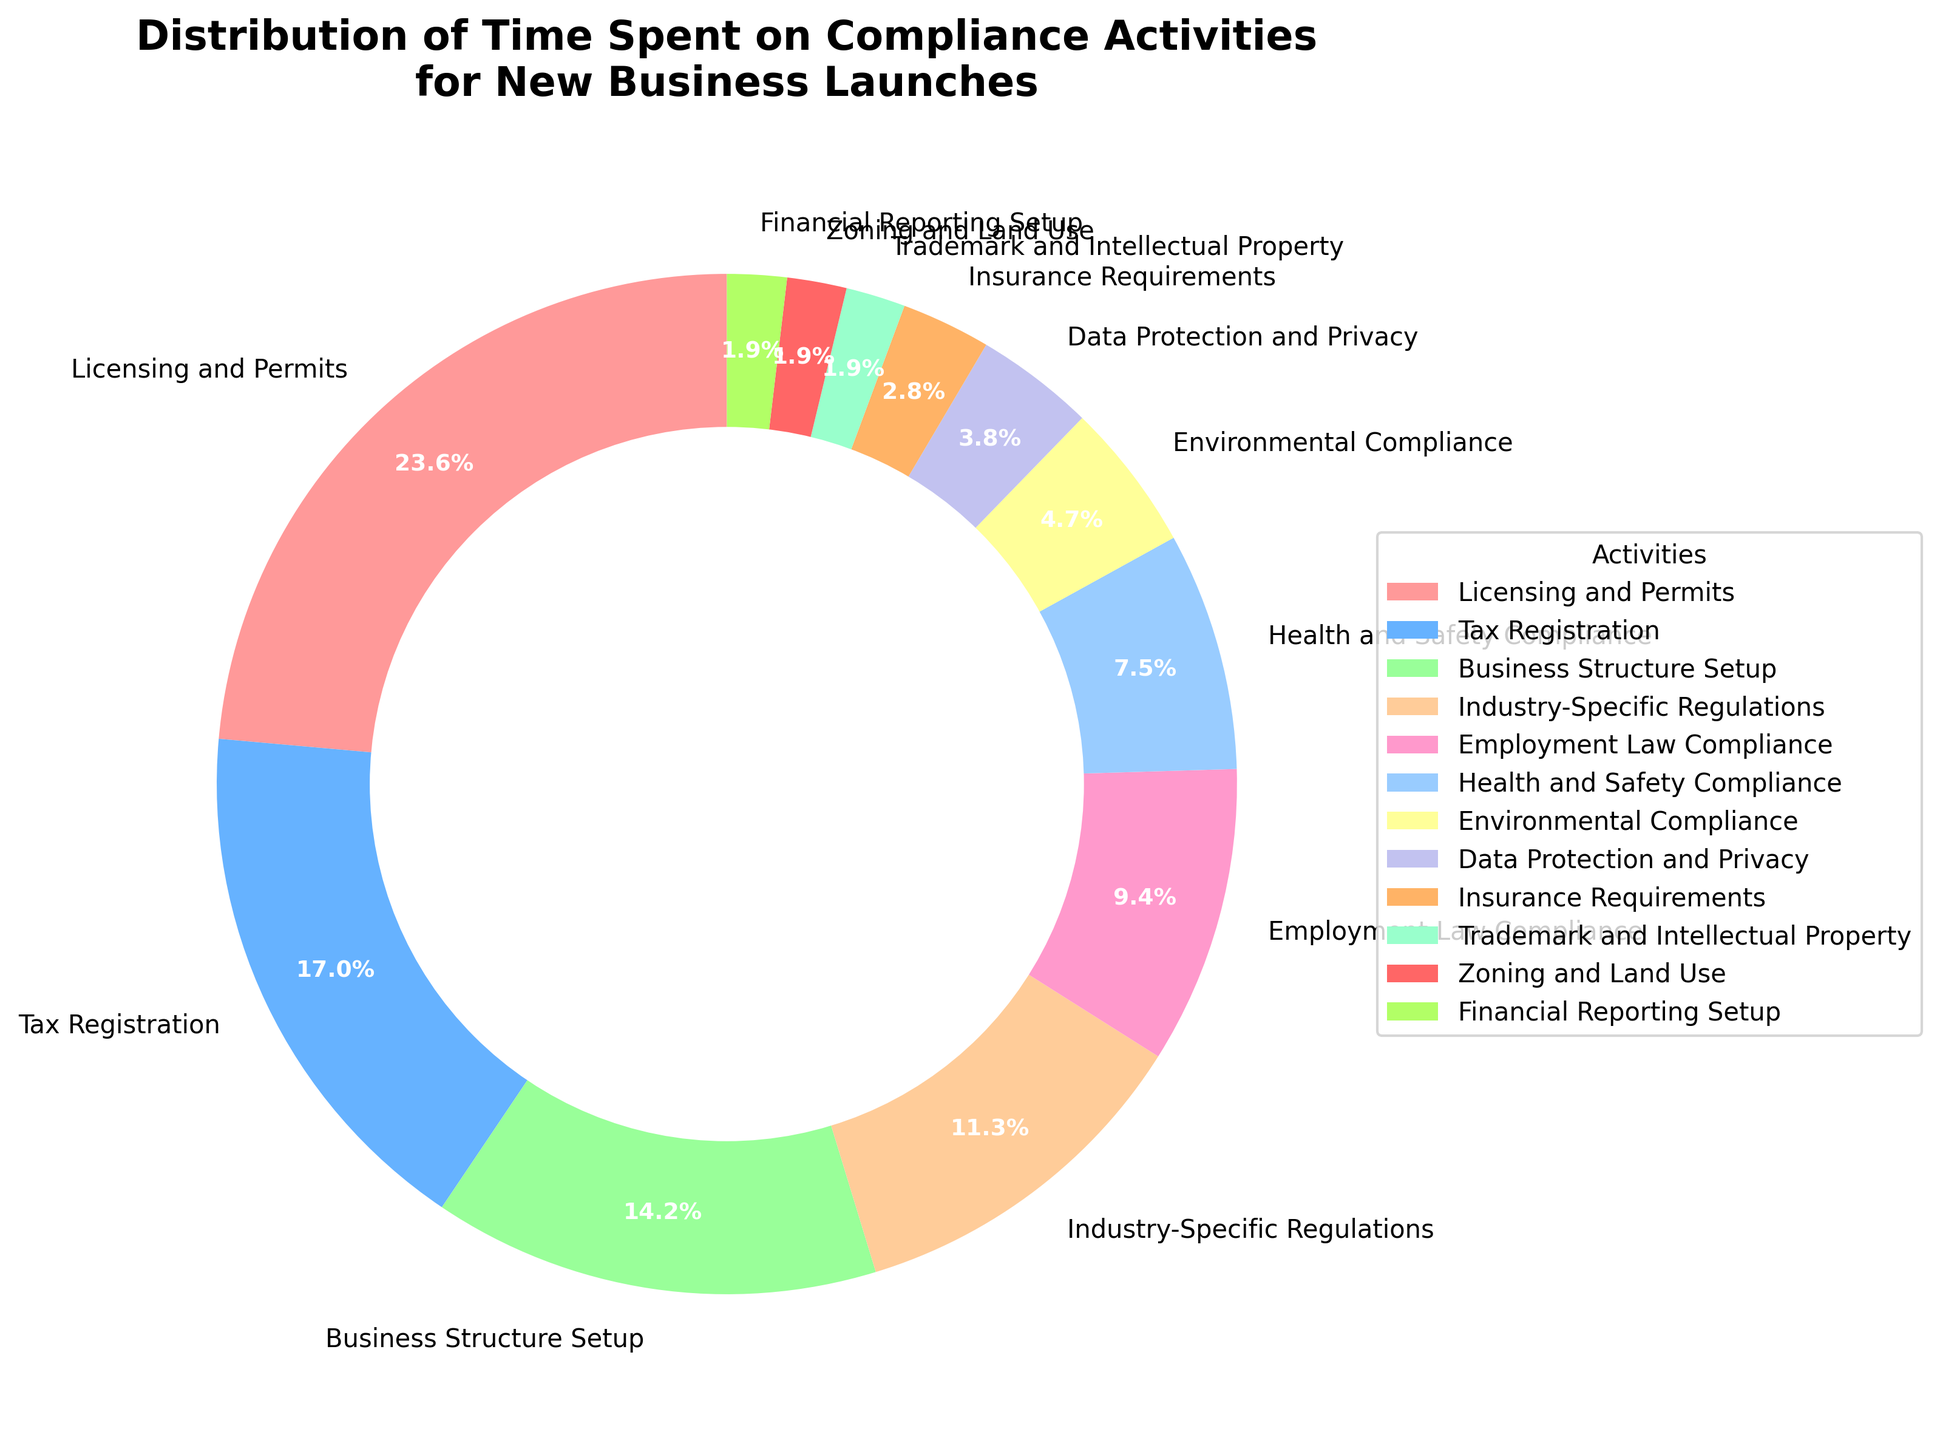What activity takes up the largest proportion of time in compliance tasks for new business launches? By looking at the pie chart, we can see that the largest wedge is labeled "Licensing and Permits" with 25% of the time allocated to this activity.
Answer: Licensing and Permits How much more time is spent on Licensing and Permits compared to Tax Registration? Licensing and Permits takes up 25% of the time, while Tax Registration takes up 18%. The difference in time spent is 25% - 18% = 7%.
Answer: 7% Which compliance activity takes up the least proportion of time? By observing the smallest wedge in the pie chart, "Zoning and Land Use" along with "Financial Reporting Setup", both taking up 2% of the time each, are the smallest.
Answer: Zoning and Land Use; Financial Reporting Setup What is the total percentage of time spent on Health and Safety Compliance, Environmental Compliance, and Data Protection and Privacy combined? Health and Safety Compliance is 8%, Environmental Compliance is 5%, and Data Protection and Privacy is 4%. Adding these together: 8% + 5% + 4% = 17%.
Answer: 17% How does the time spent on Employment Law Compliance compare to Health and Safety Compliance? Employment Law Compliance takes 10% of the time, while Health and Safety Compliance takes 8%. Therefore, more time is spent on Employment Law Compliance by a difference of 2%.
Answer: Employment Law Compliance takes 2% more time What is the combined percentage of time spent on Industry-Specific Regulations and Insurance Requirements? Industry-Specific Regulations account for 12%, and Insurance Requirements account for 3%. Adding them together: 12% + 3% = 15%.
Answer: 15% Which compliance activity has a similar proportion of time to Business Structure Setup? Business Structure Setup accounts for 15% of the time. The closest other percentages are Industry-Specific Regulations at 12% and Tax Registration at 18%. Neither are exactly the same, but Tax Registration is the closest.
Answer: Tax Registration On what activities is less than 10% of the time spent each? Activities with less than 10% each include Health and Safety Compliance (8%), Environmental Compliance (5%), Data Protection and Privacy (4%), Insurance Requirements (3%), Trademark and Intellectual Property (2%), Zoning and Land Use (2%), and Financial Reporting Setup (2%).
Answer: Health and Safety Compliance, Environmental Compliance, Data Protection and Privacy, Insurance Requirements, Trademark and Intellectual Property, Zoning and Land Use, Financial Reporting Setup What is the difference in percentage points between the time spent on Industry-Specific Regulations and Data Protection and Privacy? Industry-Specific Regulations take up 12% of the time while Data Protection and Privacy take up 4%. The difference is 12% - 4% = 8%.
Answer: 8% 